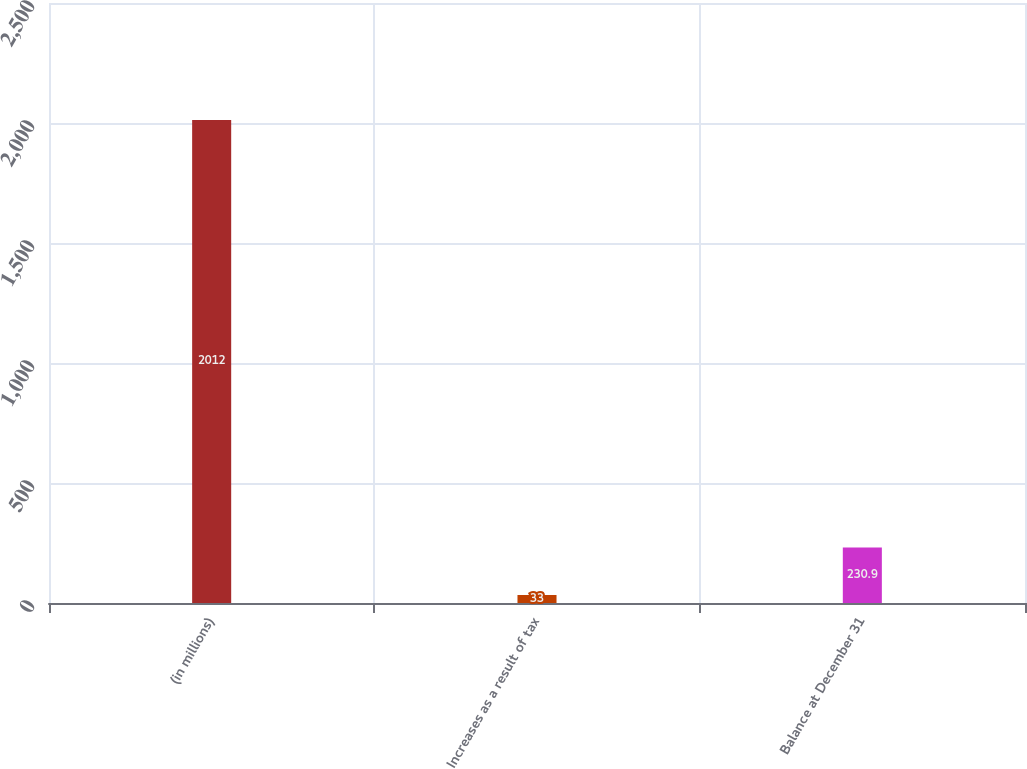Convert chart to OTSL. <chart><loc_0><loc_0><loc_500><loc_500><bar_chart><fcel>(in millions)<fcel>Increases as a result of tax<fcel>Balance at December 31<nl><fcel>2012<fcel>33<fcel>230.9<nl></chart> 